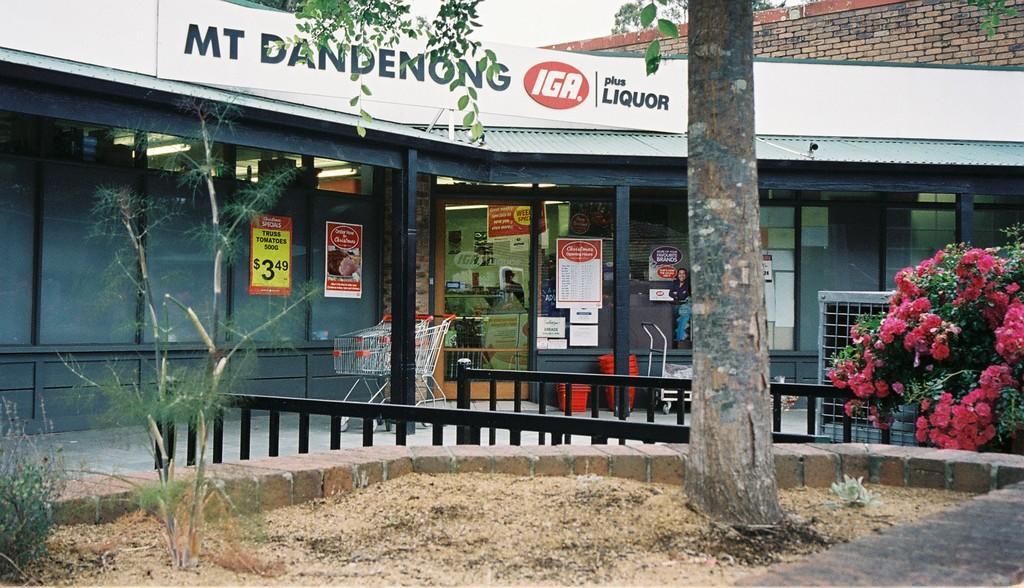Could you give a brief overview of what you see in this image? This is an outside view. In the foreground, I can see a tree trunk. On the left side there are some plants. On the right side, I can see a plant along with the flowers which are in pink color. In the background I can see a building. There are many posters are attached to the glasses. In front of this building there are some baskets and wheel baskets. At the top, I can see a board on which I can see some text. 